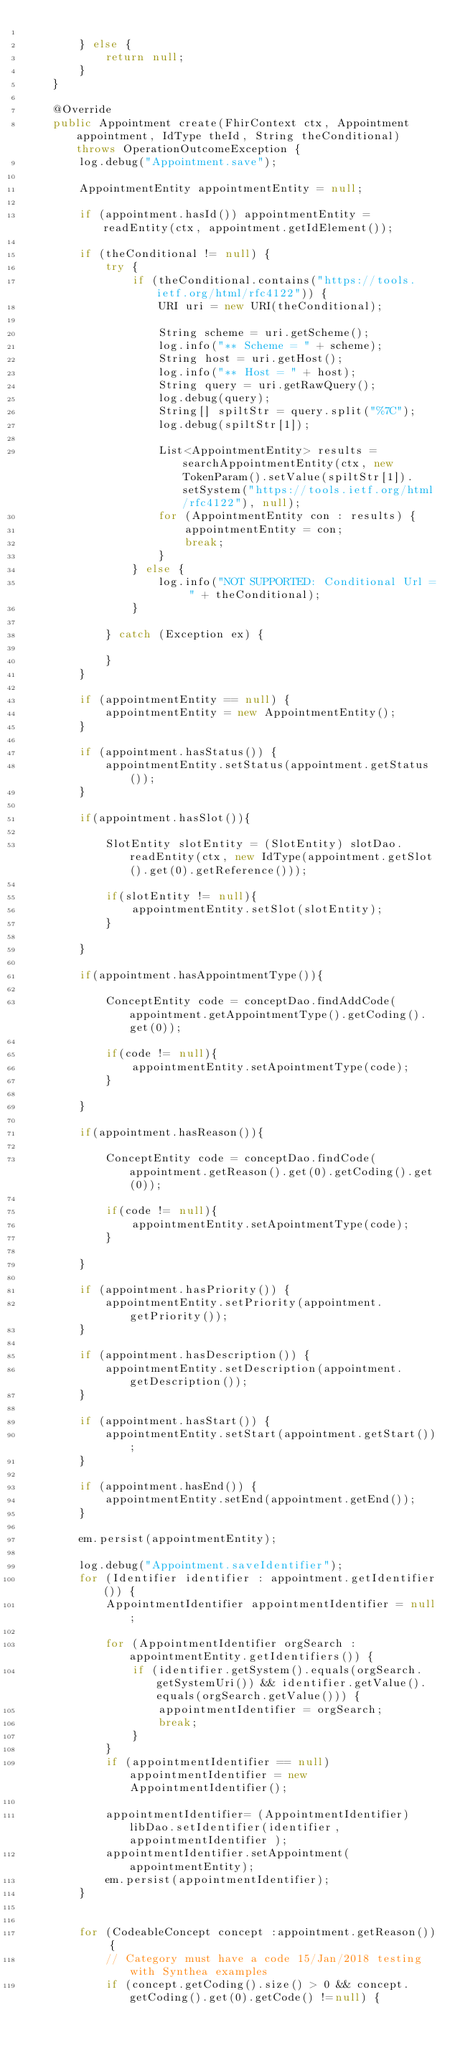Convert code to text. <code><loc_0><loc_0><loc_500><loc_500><_Java_>
        } else {
            return null;
        }
    }

    @Override
    public Appointment create(FhirContext ctx, Appointment appointment, IdType theId, String theConditional) throws OperationOutcomeException {
        log.debug("Appointment.save");

        AppointmentEntity appointmentEntity = null;

        if (appointment.hasId()) appointmentEntity = readEntity(ctx, appointment.getIdElement());

        if (theConditional != null) {
            try {
                if (theConditional.contains("https://tools.ietf.org/html/rfc4122")) {
                    URI uri = new URI(theConditional);

                    String scheme = uri.getScheme();
                    log.info("** Scheme = " + scheme);
                    String host = uri.getHost();
                    log.info("** Host = " + host);
                    String query = uri.getRawQuery();
                    log.debug(query);
                    String[] spiltStr = query.split("%7C");
                    log.debug(spiltStr[1]);

                    List<AppointmentEntity> results = searchAppointmentEntity(ctx, new TokenParam().setValue(spiltStr[1]).setSystem("https://tools.ietf.org/html/rfc4122"), null);
                    for (AppointmentEntity con : results) {
                        appointmentEntity = con;
                        break;
                    }
                } else {
                    log.info("NOT SUPPORTED: Conditional Url = " + theConditional);
                }

            } catch (Exception ex) {

            }
        }

        if (appointmentEntity == null) {
            appointmentEntity = new AppointmentEntity();
        }

        if (appointment.hasStatus()) {
            appointmentEntity.setStatus(appointment.getStatus());
        }

        if(appointment.hasSlot()){

            SlotEntity slotEntity = (SlotEntity) slotDao.readEntity(ctx, new IdType(appointment.getSlot().get(0).getReference()));

            if(slotEntity != null){
                appointmentEntity.setSlot(slotEntity);
            }

        }

        if(appointment.hasAppointmentType()){

            ConceptEntity code = conceptDao.findAddCode(appointment.getAppointmentType().getCoding().get(0));

            if(code != null){
                appointmentEntity.setApointmentType(code);
            }

        }

        if(appointment.hasReason()){

            ConceptEntity code = conceptDao.findCode(appointment.getReason().get(0).getCoding().get(0));

            if(code != null){
                appointmentEntity.setApointmentType(code);
            }

        }

        if (appointment.hasPriority()) {
            appointmentEntity.setPriority(appointment.getPriority());
        }

        if (appointment.hasDescription()) {
            appointmentEntity.setDescription(appointment.getDescription());
        }

        if (appointment.hasStart()) {
            appointmentEntity.setStart(appointment.getStart());
        }

        if (appointment.hasEnd()) {
            appointmentEntity.setEnd(appointment.getEnd());
        }

        em.persist(appointmentEntity);

        log.debug("Appointment.saveIdentifier");
        for (Identifier identifier : appointment.getIdentifier()) {
            AppointmentIdentifier appointmentIdentifier = null;

            for (AppointmentIdentifier orgSearch : appointmentEntity.getIdentifiers()) {
                if (identifier.getSystem().equals(orgSearch.getSystemUri()) && identifier.getValue().equals(orgSearch.getValue())) {
                    appointmentIdentifier = orgSearch;
                    break;
                }
            }
            if (appointmentIdentifier == null)  appointmentIdentifier = new AppointmentIdentifier();

            appointmentIdentifier= (AppointmentIdentifier) libDao.setIdentifier(identifier, appointmentIdentifier );
            appointmentIdentifier.setAppointment(appointmentEntity);
            em.persist(appointmentIdentifier);
        }


        for (CodeableConcept concept :appointment.getReason()) {
            // Category must have a code 15/Jan/2018 testing with Synthea examples
            if (concept.getCoding().size() > 0 && concept.getCoding().get(0).getCode() !=null) {</code> 